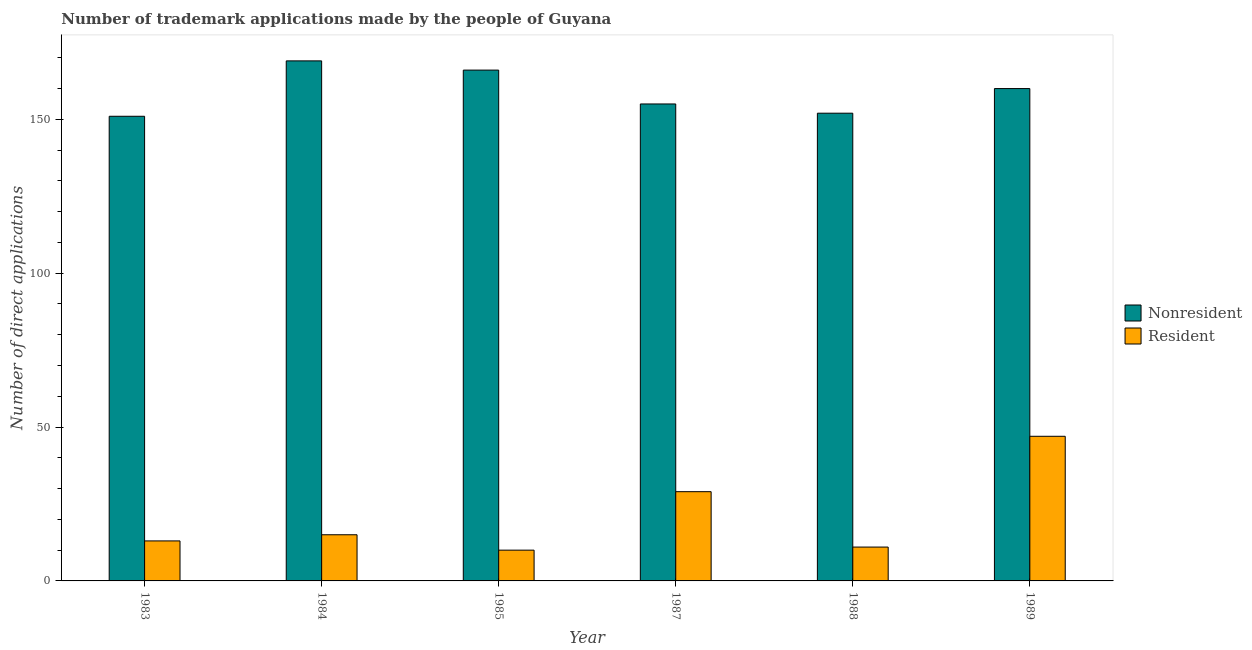Are the number of bars per tick equal to the number of legend labels?
Provide a short and direct response. Yes. How many bars are there on the 2nd tick from the left?
Your answer should be very brief. 2. How many bars are there on the 1st tick from the right?
Your response must be concise. 2. In how many cases, is the number of bars for a given year not equal to the number of legend labels?
Give a very brief answer. 0. What is the number of trademark applications made by non residents in 1988?
Keep it short and to the point. 152. Across all years, what is the maximum number of trademark applications made by non residents?
Your answer should be very brief. 169. Across all years, what is the minimum number of trademark applications made by residents?
Provide a succinct answer. 10. In which year was the number of trademark applications made by non residents maximum?
Give a very brief answer. 1984. What is the total number of trademark applications made by residents in the graph?
Keep it short and to the point. 125. What is the difference between the number of trademark applications made by residents in 1984 and that in 1985?
Offer a very short reply. 5. What is the difference between the number of trademark applications made by non residents in 1984 and the number of trademark applications made by residents in 1989?
Provide a succinct answer. 9. What is the average number of trademark applications made by residents per year?
Offer a terse response. 20.83. What is the ratio of the number of trademark applications made by residents in 1984 to that in 1989?
Make the answer very short. 0.32. Is the number of trademark applications made by residents in 1985 less than that in 1988?
Give a very brief answer. Yes. What is the difference between the highest and the lowest number of trademark applications made by non residents?
Provide a short and direct response. 18. What does the 1st bar from the left in 1989 represents?
Your answer should be very brief. Nonresident. What does the 1st bar from the right in 1983 represents?
Keep it short and to the point. Resident. Are the values on the major ticks of Y-axis written in scientific E-notation?
Your answer should be compact. No. How are the legend labels stacked?
Give a very brief answer. Vertical. What is the title of the graph?
Provide a short and direct response. Number of trademark applications made by the people of Guyana. What is the label or title of the X-axis?
Offer a very short reply. Year. What is the label or title of the Y-axis?
Your answer should be very brief. Number of direct applications. What is the Number of direct applications in Nonresident in 1983?
Offer a terse response. 151. What is the Number of direct applications in Resident in 1983?
Provide a short and direct response. 13. What is the Number of direct applications in Nonresident in 1984?
Give a very brief answer. 169. What is the Number of direct applications of Resident in 1984?
Provide a short and direct response. 15. What is the Number of direct applications of Nonresident in 1985?
Provide a short and direct response. 166. What is the Number of direct applications of Resident in 1985?
Keep it short and to the point. 10. What is the Number of direct applications of Nonresident in 1987?
Offer a terse response. 155. What is the Number of direct applications of Nonresident in 1988?
Ensure brevity in your answer.  152. What is the Number of direct applications in Resident in 1988?
Your answer should be compact. 11. What is the Number of direct applications of Nonresident in 1989?
Offer a very short reply. 160. Across all years, what is the maximum Number of direct applications of Nonresident?
Ensure brevity in your answer.  169. Across all years, what is the minimum Number of direct applications of Nonresident?
Your answer should be compact. 151. What is the total Number of direct applications in Nonresident in the graph?
Your response must be concise. 953. What is the total Number of direct applications in Resident in the graph?
Make the answer very short. 125. What is the difference between the Number of direct applications of Nonresident in 1983 and that in 1984?
Make the answer very short. -18. What is the difference between the Number of direct applications in Nonresident in 1983 and that in 1985?
Ensure brevity in your answer.  -15. What is the difference between the Number of direct applications in Resident in 1983 and that in 1985?
Keep it short and to the point. 3. What is the difference between the Number of direct applications of Resident in 1983 and that in 1987?
Offer a terse response. -16. What is the difference between the Number of direct applications of Nonresident in 1983 and that in 1988?
Your answer should be compact. -1. What is the difference between the Number of direct applications of Resident in 1983 and that in 1988?
Provide a succinct answer. 2. What is the difference between the Number of direct applications of Nonresident in 1983 and that in 1989?
Your answer should be very brief. -9. What is the difference between the Number of direct applications in Resident in 1983 and that in 1989?
Offer a very short reply. -34. What is the difference between the Number of direct applications of Nonresident in 1984 and that in 1985?
Offer a very short reply. 3. What is the difference between the Number of direct applications in Resident in 1984 and that in 1985?
Your response must be concise. 5. What is the difference between the Number of direct applications in Nonresident in 1984 and that in 1987?
Give a very brief answer. 14. What is the difference between the Number of direct applications of Resident in 1984 and that in 1987?
Offer a very short reply. -14. What is the difference between the Number of direct applications of Nonresident in 1984 and that in 1988?
Keep it short and to the point. 17. What is the difference between the Number of direct applications of Resident in 1984 and that in 1989?
Ensure brevity in your answer.  -32. What is the difference between the Number of direct applications of Nonresident in 1985 and that in 1987?
Your response must be concise. 11. What is the difference between the Number of direct applications in Nonresident in 1985 and that in 1989?
Offer a very short reply. 6. What is the difference between the Number of direct applications in Resident in 1985 and that in 1989?
Provide a short and direct response. -37. What is the difference between the Number of direct applications of Nonresident in 1987 and that in 1988?
Your response must be concise. 3. What is the difference between the Number of direct applications in Nonresident in 1987 and that in 1989?
Keep it short and to the point. -5. What is the difference between the Number of direct applications in Resident in 1987 and that in 1989?
Give a very brief answer. -18. What is the difference between the Number of direct applications in Nonresident in 1988 and that in 1989?
Give a very brief answer. -8. What is the difference between the Number of direct applications in Resident in 1988 and that in 1989?
Keep it short and to the point. -36. What is the difference between the Number of direct applications in Nonresident in 1983 and the Number of direct applications in Resident in 1984?
Provide a succinct answer. 136. What is the difference between the Number of direct applications in Nonresident in 1983 and the Number of direct applications in Resident in 1985?
Provide a succinct answer. 141. What is the difference between the Number of direct applications in Nonresident in 1983 and the Number of direct applications in Resident in 1987?
Make the answer very short. 122. What is the difference between the Number of direct applications of Nonresident in 1983 and the Number of direct applications of Resident in 1988?
Provide a short and direct response. 140. What is the difference between the Number of direct applications in Nonresident in 1983 and the Number of direct applications in Resident in 1989?
Ensure brevity in your answer.  104. What is the difference between the Number of direct applications in Nonresident in 1984 and the Number of direct applications in Resident in 1985?
Your answer should be very brief. 159. What is the difference between the Number of direct applications of Nonresident in 1984 and the Number of direct applications of Resident in 1987?
Offer a very short reply. 140. What is the difference between the Number of direct applications in Nonresident in 1984 and the Number of direct applications in Resident in 1988?
Offer a very short reply. 158. What is the difference between the Number of direct applications of Nonresident in 1984 and the Number of direct applications of Resident in 1989?
Your answer should be compact. 122. What is the difference between the Number of direct applications of Nonresident in 1985 and the Number of direct applications of Resident in 1987?
Keep it short and to the point. 137. What is the difference between the Number of direct applications in Nonresident in 1985 and the Number of direct applications in Resident in 1988?
Provide a short and direct response. 155. What is the difference between the Number of direct applications in Nonresident in 1985 and the Number of direct applications in Resident in 1989?
Offer a very short reply. 119. What is the difference between the Number of direct applications of Nonresident in 1987 and the Number of direct applications of Resident in 1988?
Keep it short and to the point. 144. What is the difference between the Number of direct applications in Nonresident in 1987 and the Number of direct applications in Resident in 1989?
Provide a succinct answer. 108. What is the difference between the Number of direct applications in Nonresident in 1988 and the Number of direct applications in Resident in 1989?
Offer a very short reply. 105. What is the average Number of direct applications of Nonresident per year?
Give a very brief answer. 158.83. What is the average Number of direct applications in Resident per year?
Your response must be concise. 20.83. In the year 1983, what is the difference between the Number of direct applications in Nonresident and Number of direct applications in Resident?
Give a very brief answer. 138. In the year 1984, what is the difference between the Number of direct applications in Nonresident and Number of direct applications in Resident?
Offer a very short reply. 154. In the year 1985, what is the difference between the Number of direct applications of Nonresident and Number of direct applications of Resident?
Give a very brief answer. 156. In the year 1987, what is the difference between the Number of direct applications of Nonresident and Number of direct applications of Resident?
Ensure brevity in your answer.  126. In the year 1988, what is the difference between the Number of direct applications in Nonresident and Number of direct applications in Resident?
Keep it short and to the point. 141. In the year 1989, what is the difference between the Number of direct applications of Nonresident and Number of direct applications of Resident?
Make the answer very short. 113. What is the ratio of the Number of direct applications in Nonresident in 1983 to that in 1984?
Your answer should be very brief. 0.89. What is the ratio of the Number of direct applications of Resident in 1983 to that in 1984?
Offer a very short reply. 0.87. What is the ratio of the Number of direct applications of Nonresident in 1983 to that in 1985?
Ensure brevity in your answer.  0.91. What is the ratio of the Number of direct applications in Nonresident in 1983 to that in 1987?
Keep it short and to the point. 0.97. What is the ratio of the Number of direct applications of Resident in 1983 to that in 1987?
Provide a succinct answer. 0.45. What is the ratio of the Number of direct applications in Nonresident in 1983 to that in 1988?
Offer a very short reply. 0.99. What is the ratio of the Number of direct applications in Resident in 1983 to that in 1988?
Your answer should be compact. 1.18. What is the ratio of the Number of direct applications of Nonresident in 1983 to that in 1989?
Make the answer very short. 0.94. What is the ratio of the Number of direct applications in Resident in 1983 to that in 1989?
Your answer should be compact. 0.28. What is the ratio of the Number of direct applications in Nonresident in 1984 to that in 1985?
Keep it short and to the point. 1.02. What is the ratio of the Number of direct applications in Resident in 1984 to that in 1985?
Provide a short and direct response. 1.5. What is the ratio of the Number of direct applications of Nonresident in 1984 to that in 1987?
Your answer should be very brief. 1.09. What is the ratio of the Number of direct applications in Resident in 1984 to that in 1987?
Give a very brief answer. 0.52. What is the ratio of the Number of direct applications of Nonresident in 1984 to that in 1988?
Provide a short and direct response. 1.11. What is the ratio of the Number of direct applications of Resident in 1984 to that in 1988?
Offer a terse response. 1.36. What is the ratio of the Number of direct applications of Nonresident in 1984 to that in 1989?
Your answer should be compact. 1.06. What is the ratio of the Number of direct applications in Resident in 1984 to that in 1989?
Offer a terse response. 0.32. What is the ratio of the Number of direct applications of Nonresident in 1985 to that in 1987?
Offer a very short reply. 1.07. What is the ratio of the Number of direct applications of Resident in 1985 to that in 1987?
Ensure brevity in your answer.  0.34. What is the ratio of the Number of direct applications in Nonresident in 1985 to that in 1988?
Your response must be concise. 1.09. What is the ratio of the Number of direct applications of Nonresident in 1985 to that in 1989?
Ensure brevity in your answer.  1.04. What is the ratio of the Number of direct applications of Resident in 1985 to that in 1989?
Keep it short and to the point. 0.21. What is the ratio of the Number of direct applications in Nonresident in 1987 to that in 1988?
Offer a very short reply. 1.02. What is the ratio of the Number of direct applications of Resident in 1987 to that in 1988?
Your answer should be compact. 2.64. What is the ratio of the Number of direct applications of Nonresident in 1987 to that in 1989?
Provide a short and direct response. 0.97. What is the ratio of the Number of direct applications of Resident in 1987 to that in 1989?
Provide a succinct answer. 0.62. What is the ratio of the Number of direct applications of Resident in 1988 to that in 1989?
Provide a short and direct response. 0.23. 